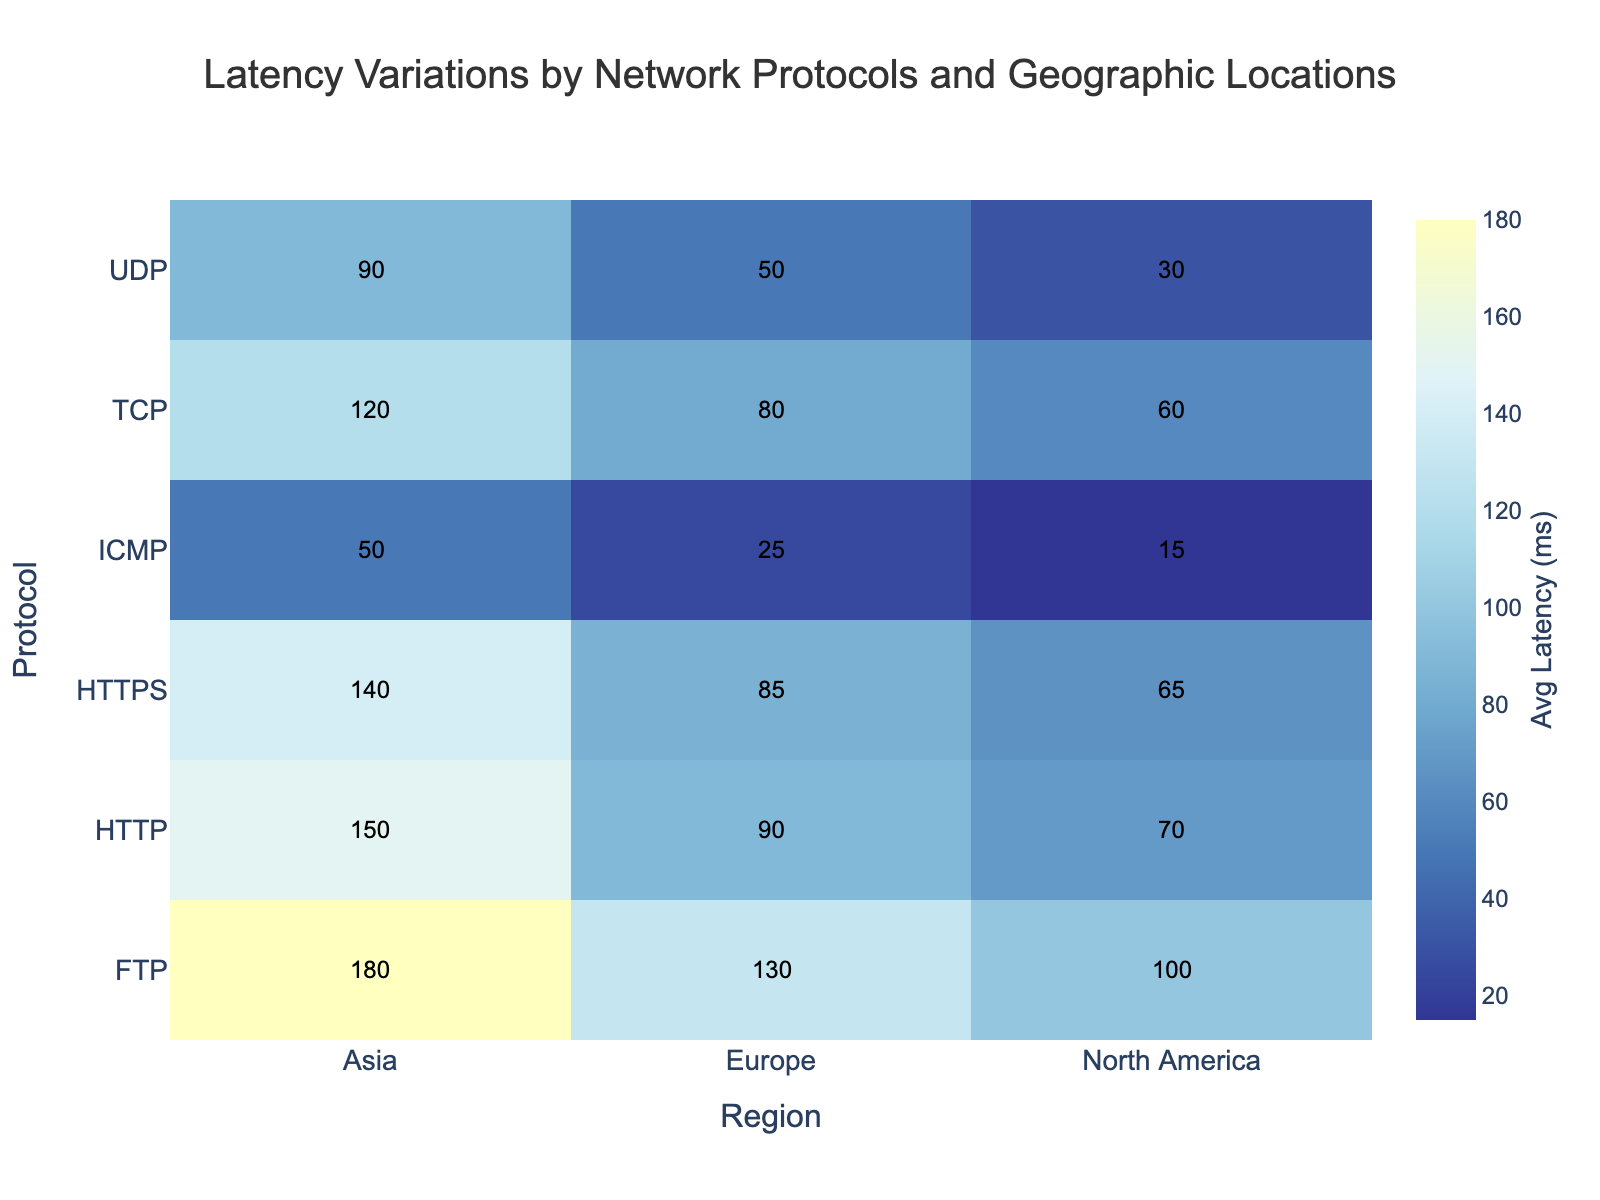what is the title of the heatmap? The heatmap's title is visible at the top of the figure. Look at the text at the top to understand the main topic of the heatmap.
Answer: Latency Variations by Network Protocols and Geographic Locations which protocol has the lowest average latency in North America? Locate the column for North America on the heatmap and then find the smallest value in that column. Check the corresponding protocol on the y-axis for that value.
Answer: ICMP what is the average latency for TCP in Asia? Find the row labeled TCP and then locate the intersection with the column for Asia. Read the value displayed in that cell.
Answer: 120ms comparing UDP and HTTP, which protocol has a higher average latency in Europe? Find the cells corresponding to UDP and HTTP in the Europe column and compare their values. Note which one is larger.
Answer: HTTP how much higher is the latency for FTP in Asia than in North America? Locate the average latency values for FTP in both Asia and North America. Subtract the North America value from the Asia value to find the difference.
Answer: 80ms which region has the smallest average latency for any protocol? Scan through the values for all regions and protocols to find the smallest number. Note the region corresponding to that value.
Answer: North America what is the difference in average latency between ICMP and HTTPS in Europe? Locate the cells for ICMP and HTTPS in the Europe column, then subtract the ICMP value from the HTTPS value to find the difference.
Answer: 60ms among all protocols, which one shows the highest latency in any region? Scan through all values on the heatmap to identify the highest number. Note the protocol and region where this highest value occurs.
Answer: FTP in Asia which region shows the most significant variation in latencies between different protocols? Compare the range of values (difference between highest and lowest) for each region by looking down each column. Identify the region with the largest range.
Answer: Asia how does the average latency for HTTP in North America compare to UDP in Asia? Locate the HTTP latency for North America and the UDP latency for Asia, then compare the two values to determine which is higher.
Answer: UDP in Asia has higher latency 